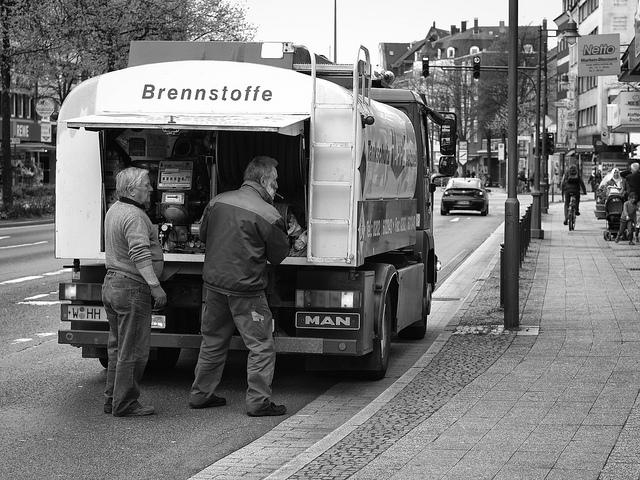What is the name on the top of the truck?
Answer briefly. Brennstoffe. What are the people doing?
Give a very brief answer. Unloading truck. Is this picture in color?
Concise answer only. No. 